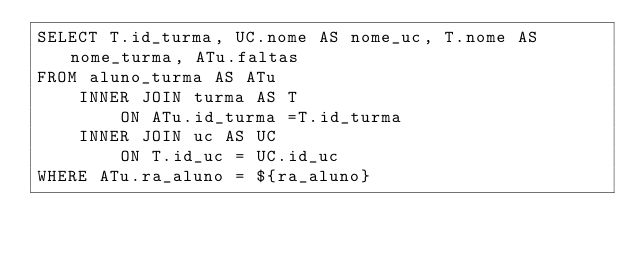<code> <loc_0><loc_0><loc_500><loc_500><_SQL_>SELECT T.id_turma, UC.nome AS nome_uc, T.nome AS nome_turma, ATu.faltas
FROM aluno_turma AS ATu
    INNER JOIN turma AS T
        ON ATu.id_turma =T.id_turma
    INNER JOIN uc AS UC
        ON T.id_uc = UC.id_uc
WHERE ATu.ra_aluno = ${ra_aluno}</code> 